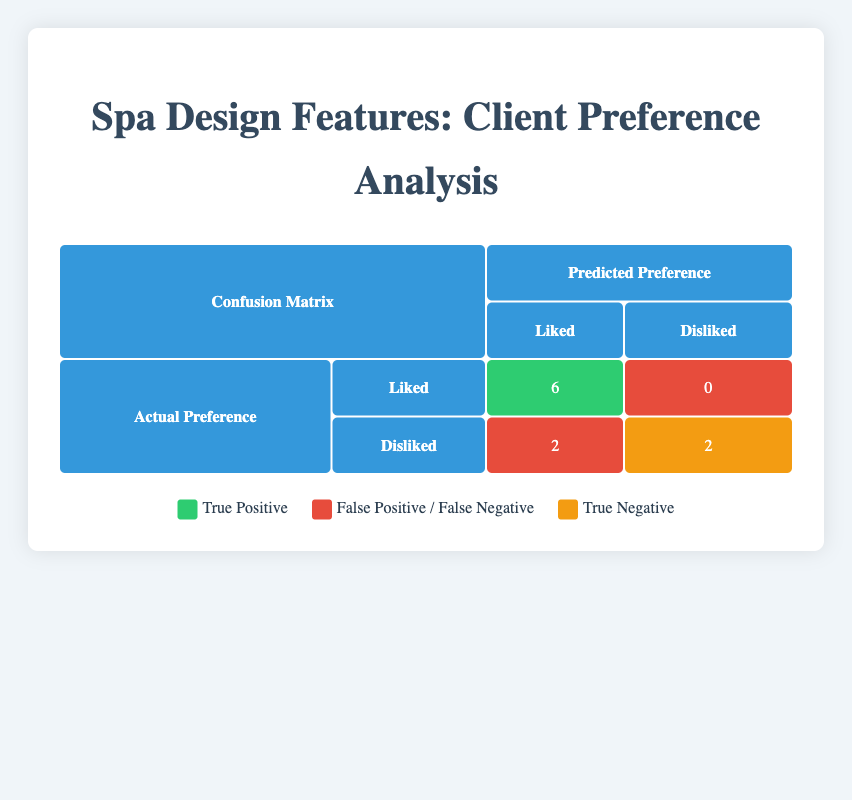What is the total number of features that clients liked? There are six features that clients liked: Waterfall Elements, Natural Light, Massage Rooms, Aromatherapy Stations, Sound Therapy Rooms, and Outdoor Lounging Space.
Answer: 6 How many features were predicted to be liked but were actually disliked? There are two features that were predicted to be liked but were actually disliked: Indoor Plants and Private Relaxation Areas.
Answer: 2 Is the predicted preference for the feature "Jacuzzi Tubs" accurate according to the actual preference? Yes, the actual preference for Jacuzzi Tubs is disliked, and the predicted preference is also disliked, indicating accuracy.
Answer: Yes What is the sum of true positives and true negatives in the table? The true positives are 6 (liked) and the true negatives are 2 (disliked). Thus, the sum is 6 + 2 = 8.
Answer: 8 How many features did clients dislike that were predicted to be liked? There were two features that clients disliked: Indoor Plants and Private Relaxation Areas, both of which were predicted to be liked.
Answer: 2 Which preference had the highest disagreement between actual and predicted? The feature with the highest disagreement is "Private Relaxation Areas" where the actual preference was disliked but predicted as liked, indicating a mismatch.
Answer: Private Relaxation Areas What proportion of features had an accurate liking prediction? There were 6 features that were correctly predicted as liked out of 8 features that were liked or disliked, so the proportion is 6/10 = 0.6 or 60%.
Answer: 60% What is the difference between the number of true positives and false positives? The number of true positives is 6 and false positives is 2. Therefore, the difference is 6 - 2 = 4.
Answer: 4 How many total features were analyzed in the preference analysis? A total of 10 features were analyzed in the preference analysis based on the provided data.
Answer: 10 